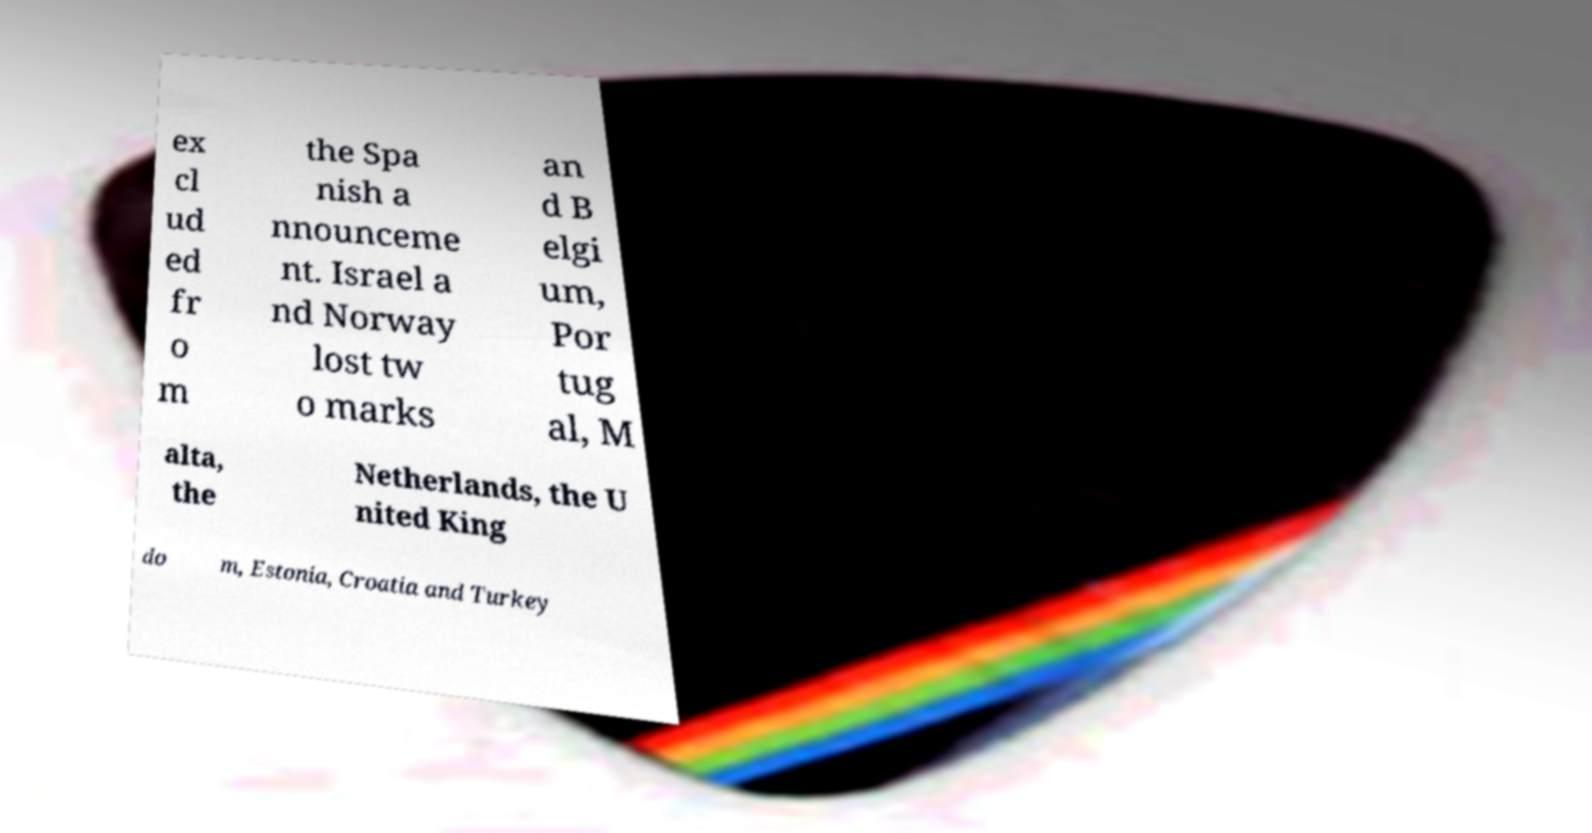Please identify and transcribe the text found in this image. ex cl ud ed fr o m the Spa nish a nnounceme nt. Israel a nd Norway lost tw o marks an d B elgi um, Por tug al, M alta, the Netherlands, the U nited King do m, Estonia, Croatia and Turkey 